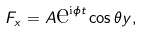Convert formula to latex. <formula><loc_0><loc_0><loc_500><loc_500>F _ { x } = A \text {e} ^ { \text {i} \phi t } \cos \theta y ,</formula> 